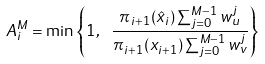<formula> <loc_0><loc_0><loc_500><loc_500>A ^ { M } _ { i } = \min \left \{ 1 , \ \frac { \pi _ { i + 1 } ( \hat { x } _ { i } ) \sum _ { j = 0 } ^ { M - 1 } w ^ { j } _ { u } } { \pi _ { i + 1 } ( x _ { i + 1 } ) \sum _ { j = 0 } ^ { M - 1 } w ^ { j } _ { v } } \right \}</formula> 